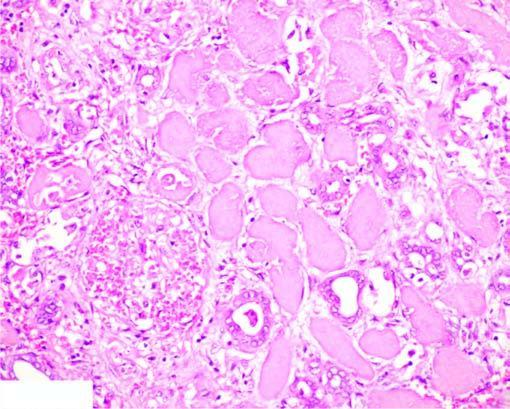what shows cells with intensely eosinophilic cytoplasm of tubular cells?
Answer the question using a single word or phrase. The affected area on right 